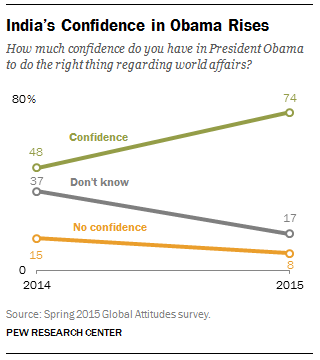Point out several critical features in this image. The average of all the values in 2015 is 33. In 2014, a significant percentage of Indians lacked confidence in President Obama's ability to make the right decisions regarding world affairs. 